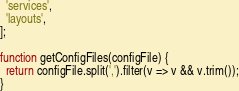Convert code to text. <code><loc_0><loc_0><loc_500><loc_500><_JavaScript_>  'services',
  'layouts',
];

function getConfigFiles(configFile) {
  return configFile.split(',').filter(v => v && v.trim());
}
</code> 